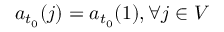<formula> <loc_0><loc_0><loc_500><loc_500>a _ { t _ { 0 } } ( j ) = a _ { t _ { 0 } } ( 1 ) , \forall j \in V</formula> 